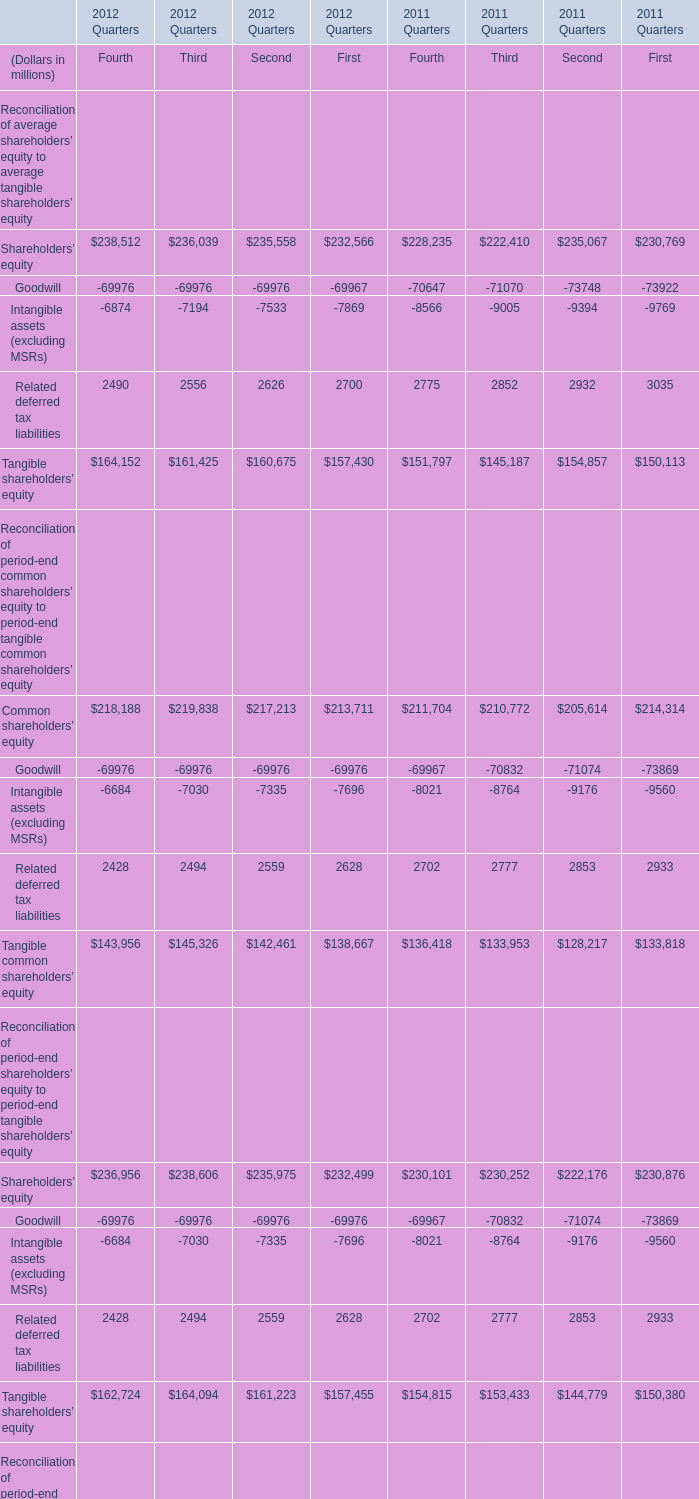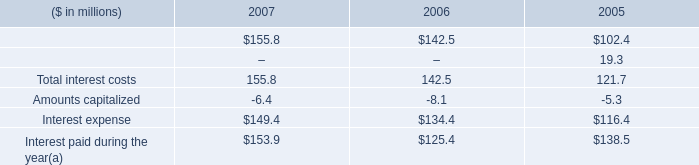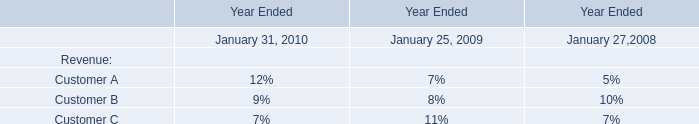what is the percentage change in interest expense from 2006 to 2007? 
Computations: ((149.4 - 134.4) / 134.4)
Answer: 0.11161. 